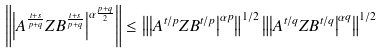<formula> <loc_0><loc_0><loc_500><loc_500>\left \| \left | A ^ { \frac { t + s } { p + q } } Z B ^ { \frac { t + s } { p + q } } \right | ^ { \alpha \frac { p + q } { 2 } } \right \| \leq \left \| \left | A ^ { t / p } Z B ^ { t / p } \right | ^ { \alpha p } \right \| ^ { 1 / 2 } \left \| \left | A ^ { t / q } Z B ^ { t / q } \right | ^ { \alpha q } \right \| ^ { 1 / 2 }</formula> 